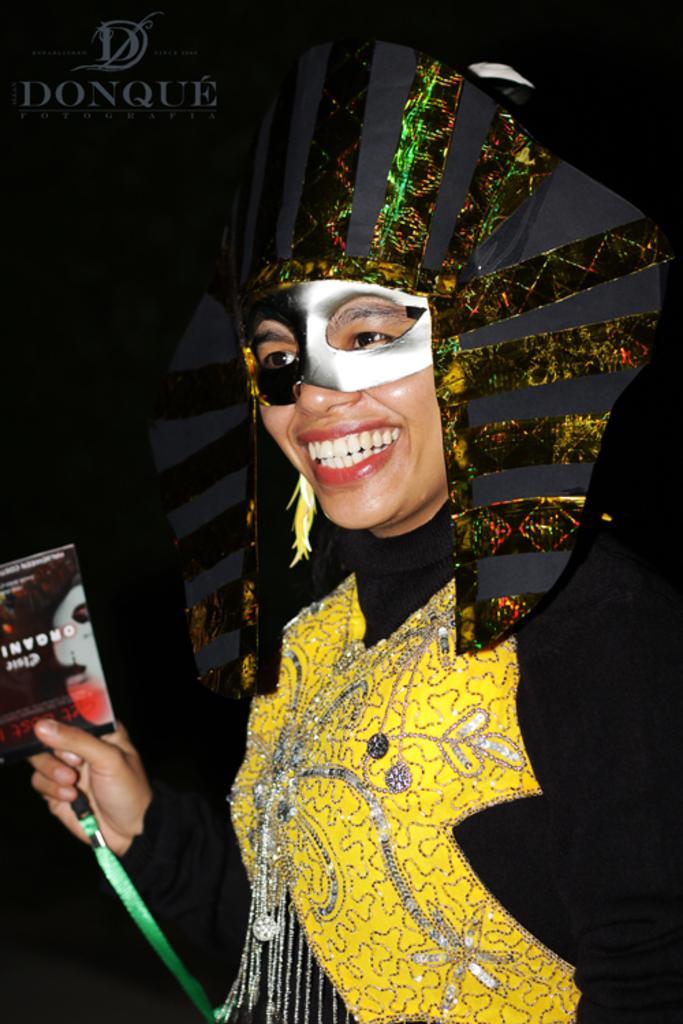How would you summarize this image in a sentence or two? In this image there is a person. The person is wearing a costume. The person is holding a small paper in the hand. There is a tag to the paper. Behind the person there is a blackboard. There is text on the board. The person is smiling. 